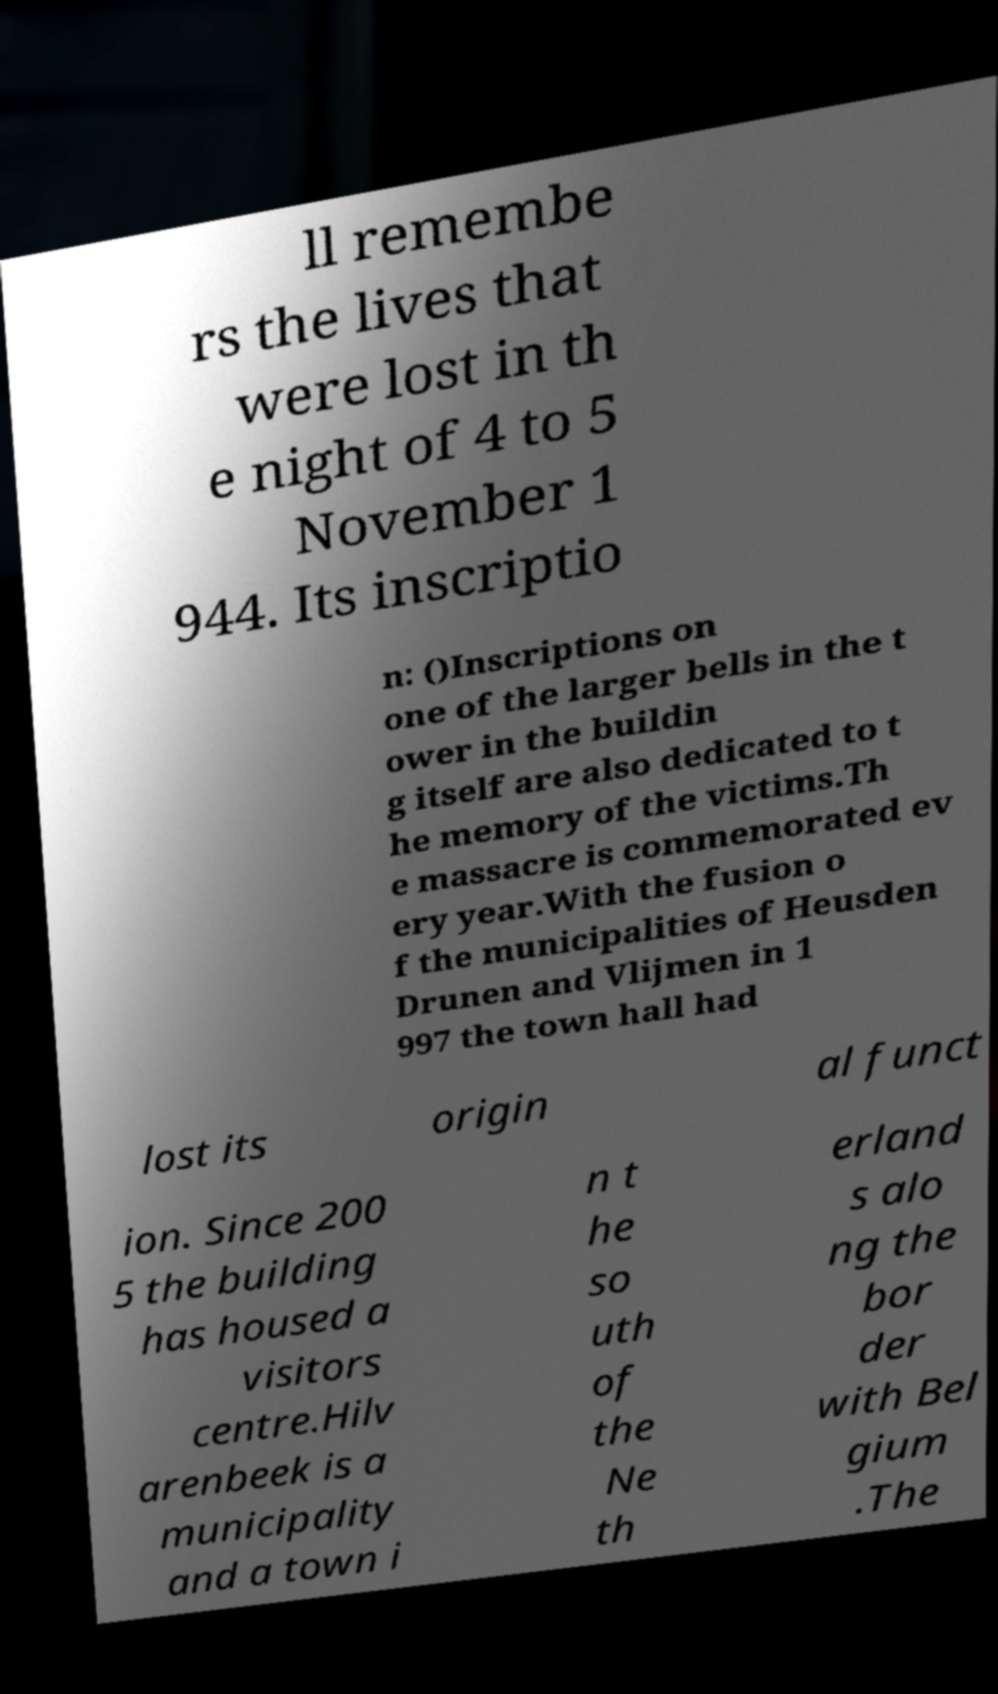Can you read and provide the text displayed in the image?This photo seems to have some interesting text. Can you extract and type it out for me? ll remembe rs the lives that were lost in th e night of 4 to 5 November 1 944. Its inscriptio n: ()Inscriptions on one of the larger bells in the t ower in the buildin g itself are also dedicated to t he memory of the victims.Th e massacre is commemorated ev ery year.With the fusion o f the municipalities of Heusden Drunen and Vlijmen in 1 997 the town hall had lost its origin al funct ion. Since 200 5 the building has housed a visitors centre.Hilv arenbeek is a municipality and a town i n t he so uth of the Ne th erland s alo ng the bor der with Bel gium .The 